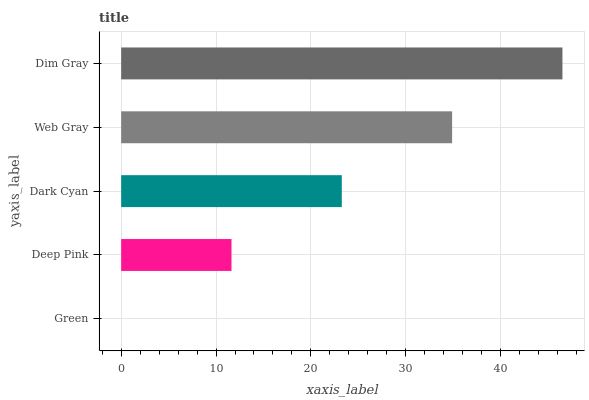Is Green the minimum?
Answer yes or no. Yes. Is Dim Gray the maximum?
Answer yes or no. Yes. Is Deep Pink the minimum?
Answer yes or no. No. Is Deep Pink the maximum?
Answer yes or no. No. Is Deep Pink greater than Green?
Answer yes or no. Yes. Is Green less than Deep Pink?
Answer yes or no. Yes. Is Green greater than Deep Pink?
Answer yes or no. No. Is Deep Pink less than Green?
Answer yes or no. No. Is Dark Cyan the high median?
Answer yes or no. Yes. Is Dark Cyan the low median?
Answer yes or no. Yes. Is Dim Gray the high median?
Answer yes or no. No. Is Web Gray the low median?
Answer yes or no. No. 